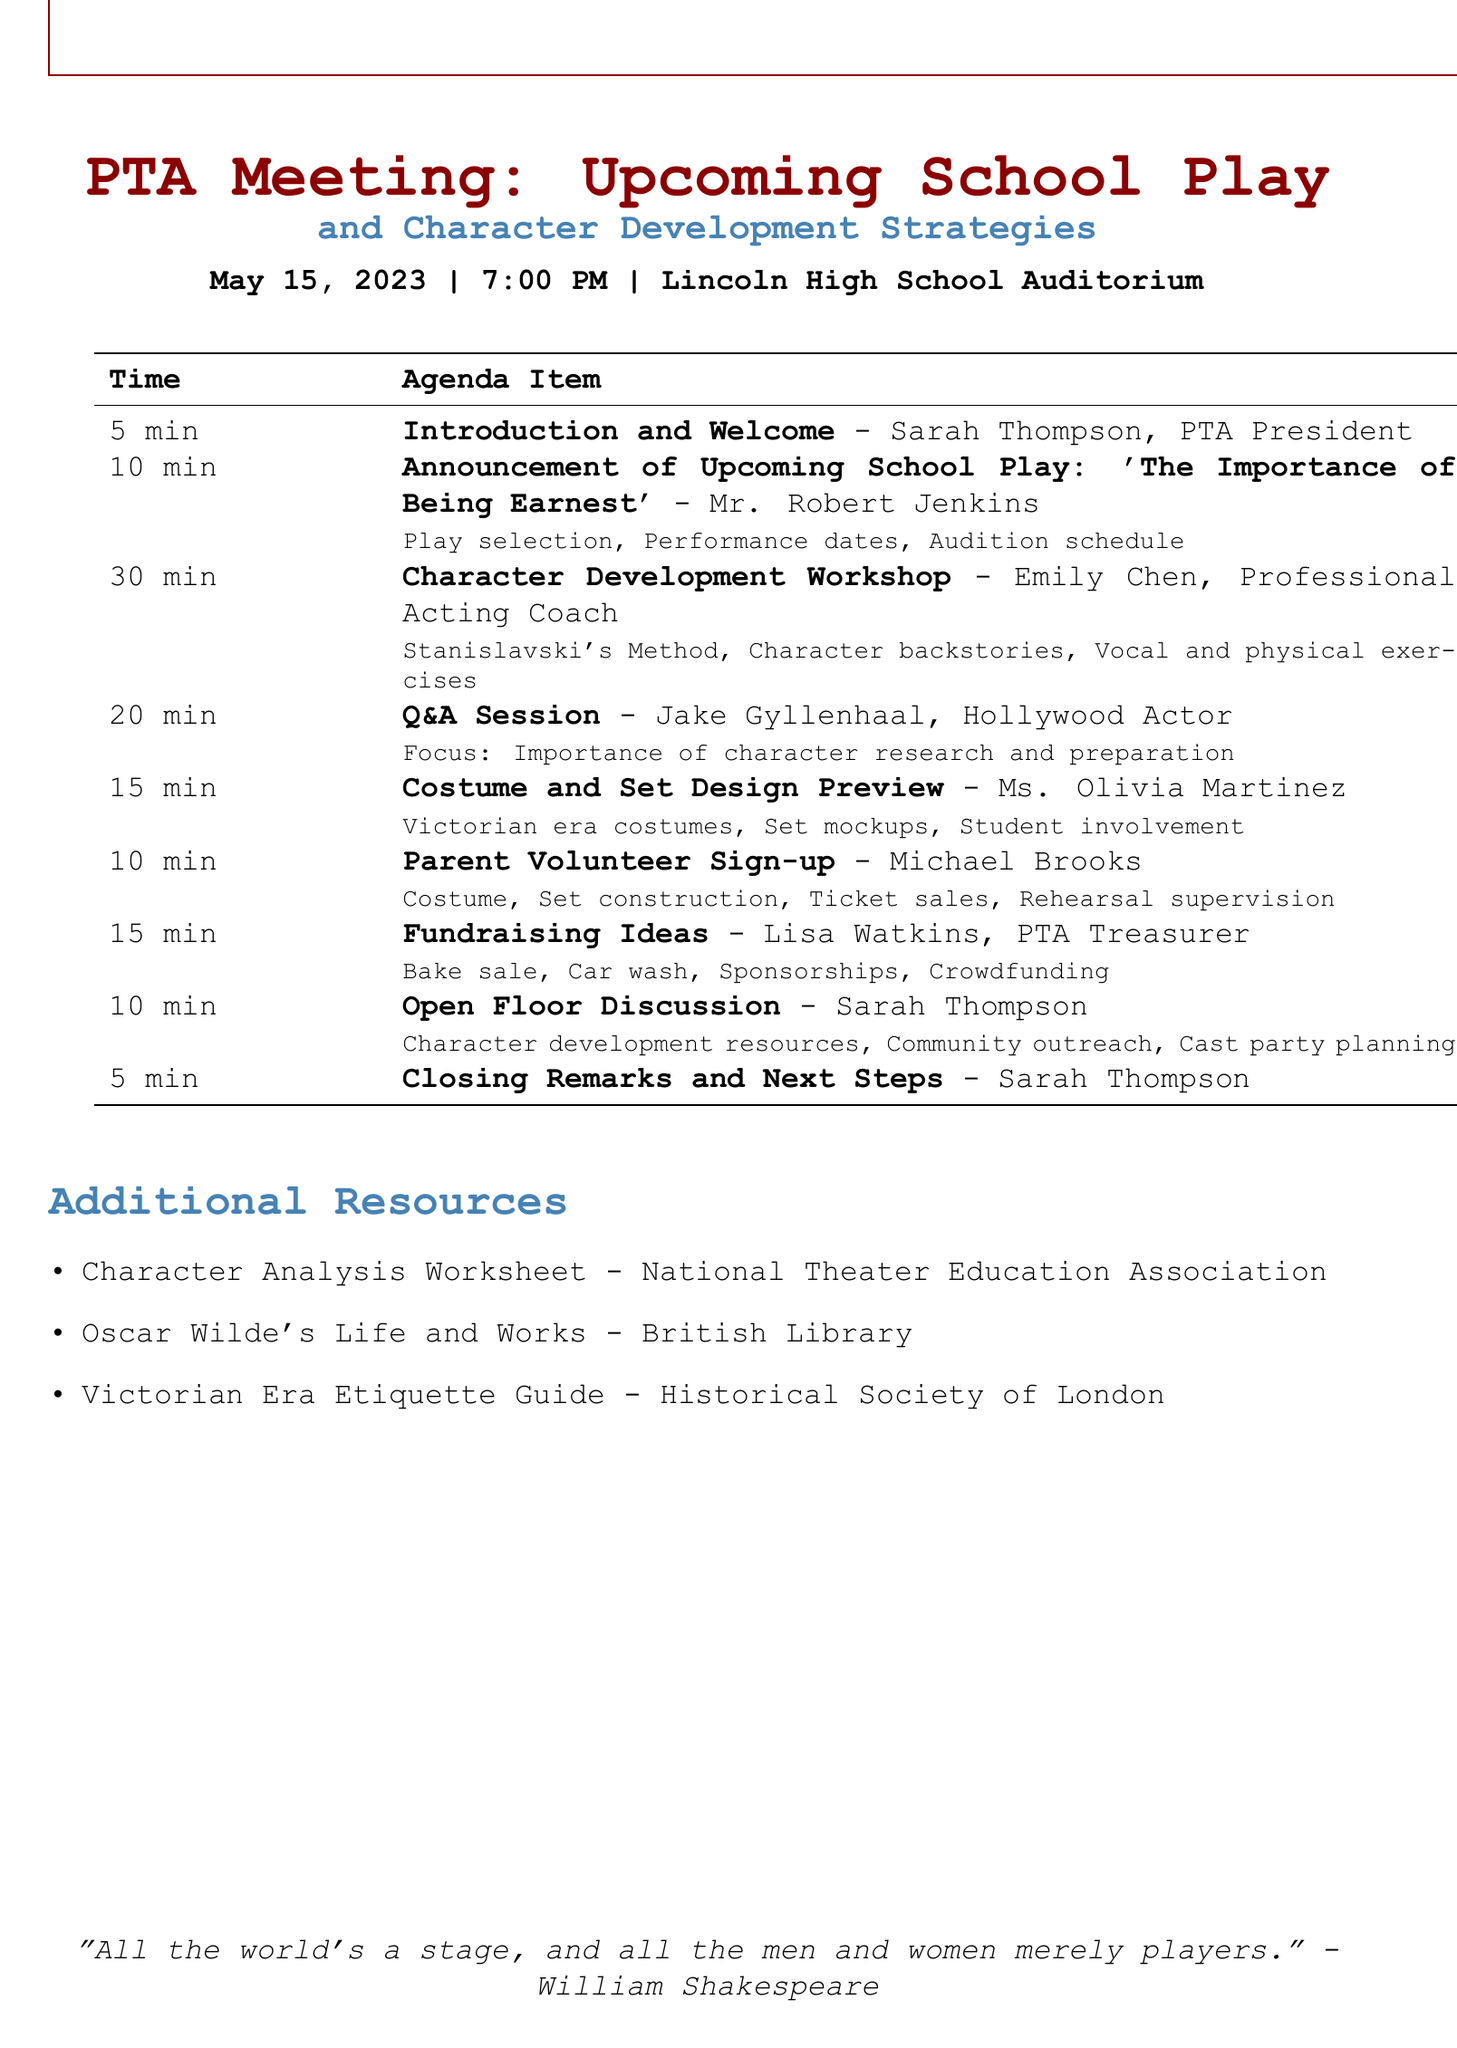What is the title of the upcoming school play? The title of the upcoming school play is mentioned in the agenda as 'The Importance of Being Earnest'.
Answer: 'The Importance of Being Earnest' Who is the presenter of the Character Development Workshop? The presenter of the Character Development Workshop is listed as Emily Chen, a Professional Acting Coach.
Answer: Emily Chen How long is the Q&A Session with the guest speaker? The duration of the Q&A Session is stated in the agenda as 20 minutes.
Answer: 20 minutes What is one fundraising suggestion mentioned in the meeting? The agenda includes multiple fundraising suggestions, one of which is a bake sale.
Answer: Bake sale What is the focus of the Q&A Session? The focus of the Q&A Session is highlighted as the importance of character research and preparation.
Answer: Importance of character research and preparation Who moderates the Open Floor Discussion? The Open Floor Discussion is moderated by Sarah Thompson, the PTA President.
Answer: Sarah Thompson What is the total duration of the Introduction and Welcome? The total duration of the Introduction and Welcome is listed as 5 minutes in the agenda.
Answer: 5 minutes 